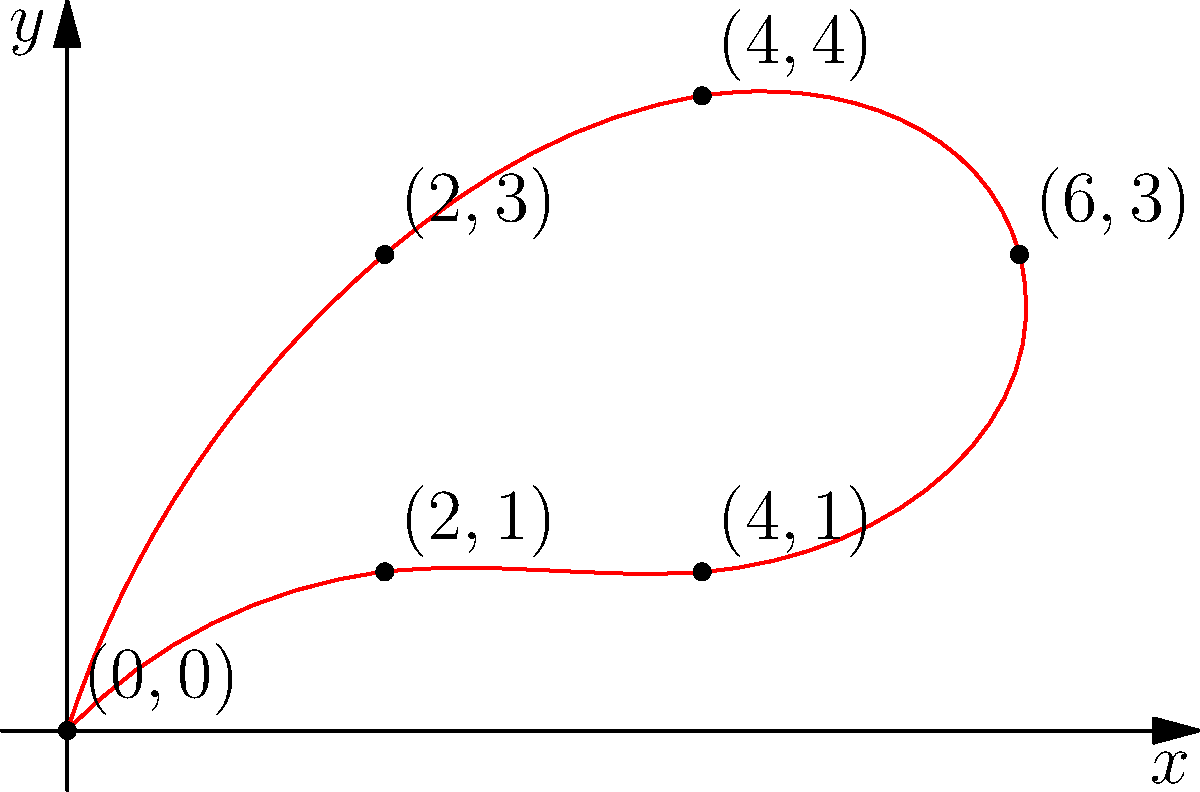You have designed a unique serving platter for traditional Saudi dishes. The platter's shape can be represented by the points in the coordinate plane shown above. Calculate the area of this irregularly shaped platter using the coordinate points given. To find the area of this irregular shape, we can use the Shoelace formula (also known as the surveyor's formula). The steps are as follows:

1) List the coordinates in order (clockwise or counterclockwise):
   $(0,0)$, $(2,3)$, $(4,4)$, $(6,3)$, $(4,1)$, $(2,1)$, $(0,0)$

2) Apply the Shoelace formula:
   $Area = \frac{1}{2}|(x_1y_2 + x_2y_3 + ... + x_ny_1) - (y_1x_2 + y_2x_3 + ... + y_nx_1)|$

3) Calculate each term:
   $(0 \cdot 3) + (2 \cdot 4) + (4 \cdot 3) + (6 \cdot 1) + (4 \cdot 1) + (2 \cdot 0) + (0 \cdot 0) = 0 + 8 + 12 + 6 + 4 + 0 + 0 = 30$
   $(0 \cdot 2) + (3 \cdot 4) + (4 \cdot 6) + (3 \cdot 4) + (1 \cdot 2) + (1 \cdot 0) + (0 \cdot 0) = 0 + 12 + 24 + 12 + 2 + 0 + 0 = 50$

4) Subtract and take the absolute value:
   $|30 - 50| = |-20| = 20$

5) Divide by 2:
   $\frac{20}{2} = 10$

Therefore, the area of the serving platter is 10 square units.
Answer: 10 square units 